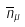<formula> <loc_0><loc_0><loc_500><loc_500>\overline { n } _ { \mu }</formula> 